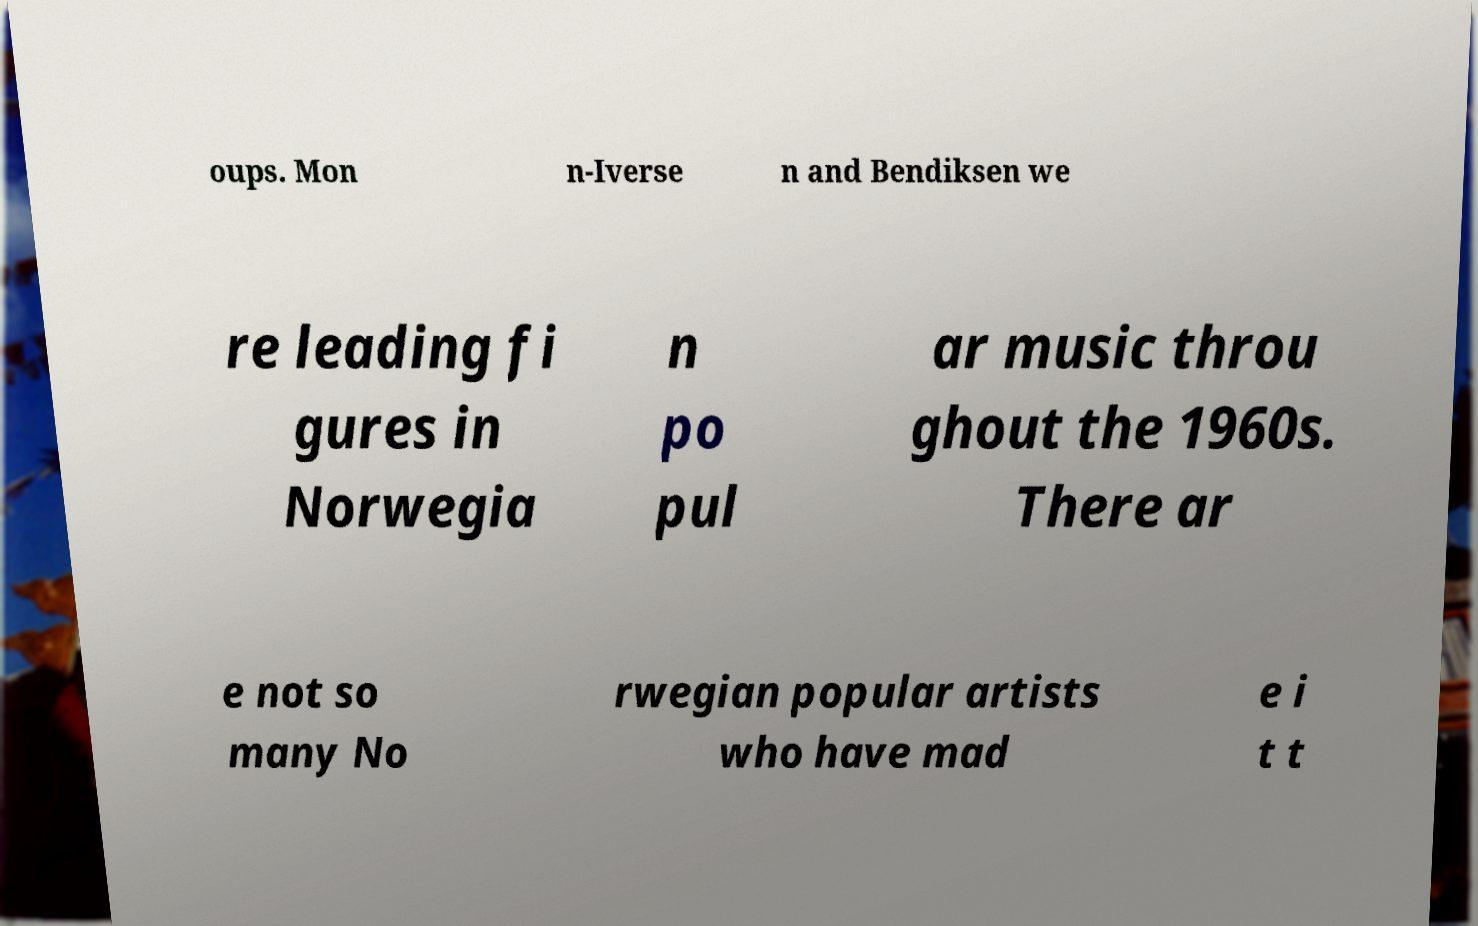There's text embedded in this image that I need extracted. Can you transcribe it verbatim? oups. Mon n-Iverse n and Bendiksen we re leading fi gures in Norwegia n po pul ar music throu ghout the 1960s. There ar e not so many No rwegian popular artists who have mad e i t t 